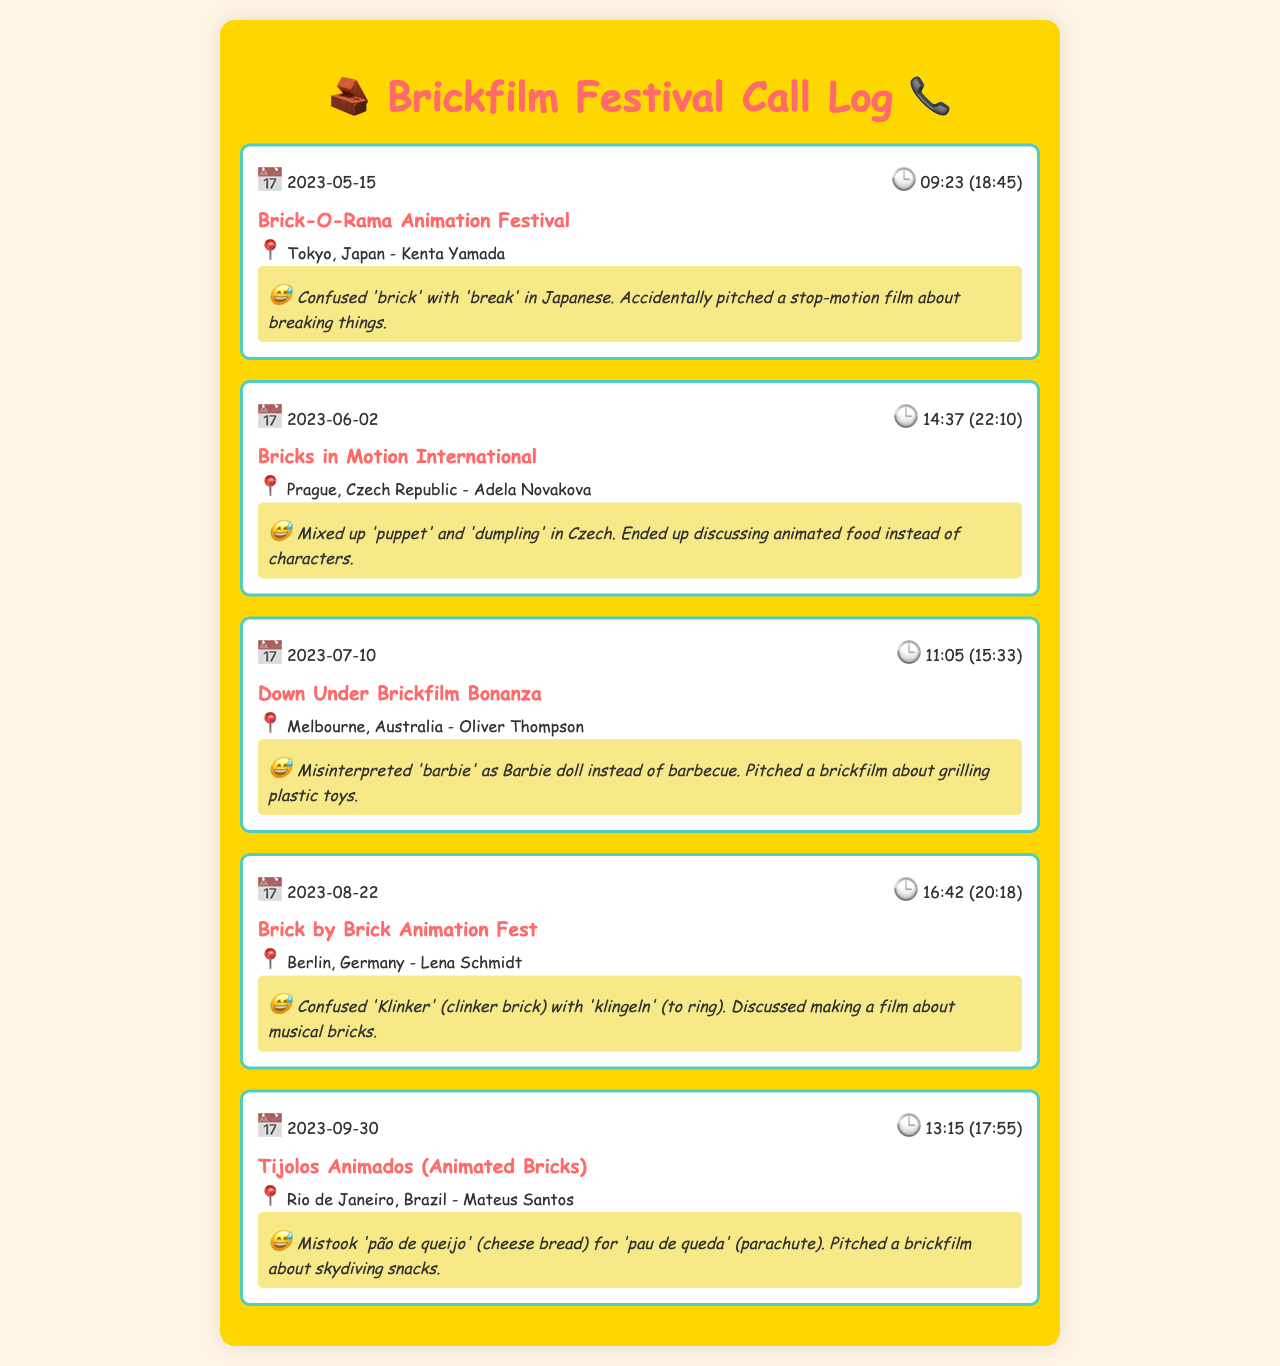What is the first festival listed? The first festival in the log is "Brick-O-Rama Animation Festival," which is found in the first call record.
Answer: Brick-O-Rama Animation Festival What date was the call made to the Down Under Brickfilm Bonanza? The call to the Down Under Brickfilm Bonanza was made on July 10, 2023, as noted in the call record.
Answer: 2023-07-10 Who is the contact person for the Brick by Brick Animation Fest? The contact person for the Brick by Brick Animation Fest is Lena Schmidt, which is indicated under the respective call record.
Answer: Lena Schmidt What humorous misunderstanding occurred during the call to Tijolos Animados? During the call to Tijolos Animados, there was a misunderstanding about 'pão de queijo' being incorrectly interpreted.
Answer: Mistook 'pão de queijo' Which festival has a contact in Prague? The festival with a contact in Prague is "Bricks in Motion International," as stated in the call record.
Answer: Bricks in Motion International How was 'brick' misunderstood in the call to Tokyo? 'Brick' was misunderstood as 'break' during the call to Tokyo, leading to a comedic pitch about breaking things.
Answer: 'Break' What was pitched during the call to the Down Under Brickfilm Bonanza? The pitch during the Down Under Brickfilm Bonanza call involved a brickfilm about grilling plastic toys due to a mix-up with 'barbie.'
Answer: Grilling plastic toys 